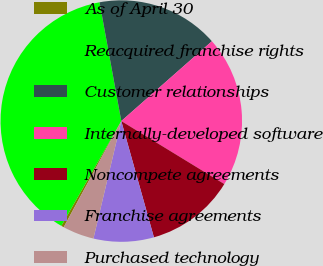Convert chart to OTSL. <chart><loc_0><loc_0><loc_500><loc_500><pie_chart><fcel>As of April 30<fcel>Reacquired franchise rights<fcel>Customer relationships<fcel>Internally-developed software<fcel>Noncompete agreements<fcel>Franchise agreements<fcel>Purchased technology<nl><fcel>0.36%<fcel>38.84%<fcel>16.39%<fcel>20.23%<fcel>11.91%<fcel>8.06%<fcel>4.21%<nl></chart> 